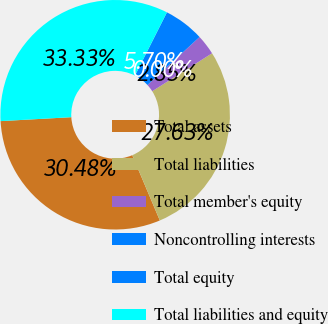Convert chart. <chart><loc_0><loc_0><loc_500><loc_500><pie_chart><fcel>Total assets<fcel>Total liabilities<fcel>Total member's equity<fcel>Noncontrolling interests<fcel>Total equity<fcel>Total liabilities and equity<nl><fcel>30.48%<fcel>27.63%<fcel>2.85%<fcel>0.0%<fcel>5.7%<fcel>33.33%<nl></chart> 